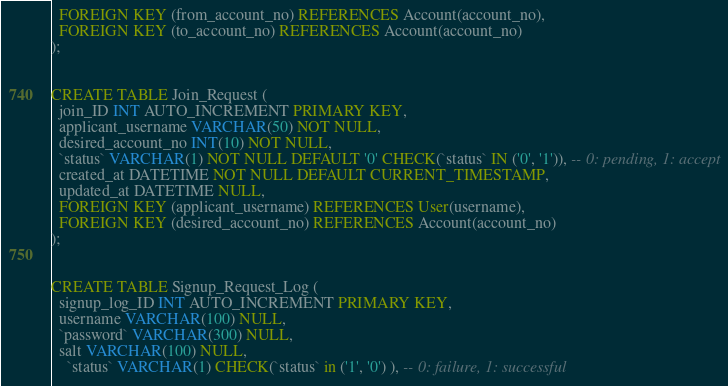Convert code to text. <code><loc_0><loc_0><loc_500><loc_500><_SQL_>  FOREIGN KEY (from_account_no) REFERENCES Account(account_no),
  FOREIGN KEY (to_account_no) REFERENCES Account(account_no)
);


CREATE TABLE Join_Request (
  join_ID INT AUTO_INCREMENT PRIMARY KEY,
  applicant_username VARCHAR(50) NOT NULL,
  desired_account_no INT(10) NOT NULL,
  `status` VARCHAR(1) NOT NULL DEFAULT '0' CHECK(`status` IN ('0', '1')), -- 0: pending, 1: accept
  created_at DATETIME NOT NULL DEFAULT CURRENT_TIMESTAMP,
  updated_at DATETIME NULL,
  FOREIGN KEY (applicant_username) REFERENCES User(username),
  FOREIGN KEY (desired_account_no) REFERENCES Account(account_no)
);


CREATE TABLE Signup_Request_Log (
  signup_log_ID INT AUTO_INCREMENT PRIMARY KEY,
  username VARCHAR(100) NULL,
  `password` VARCHAR(300) NULL,
  salt VARCHAR(100) NULL,
	`status` VARCHAR(1) CHECK(`status` in ('1', '0') ), -- 0: failure, 1: successful</code> 